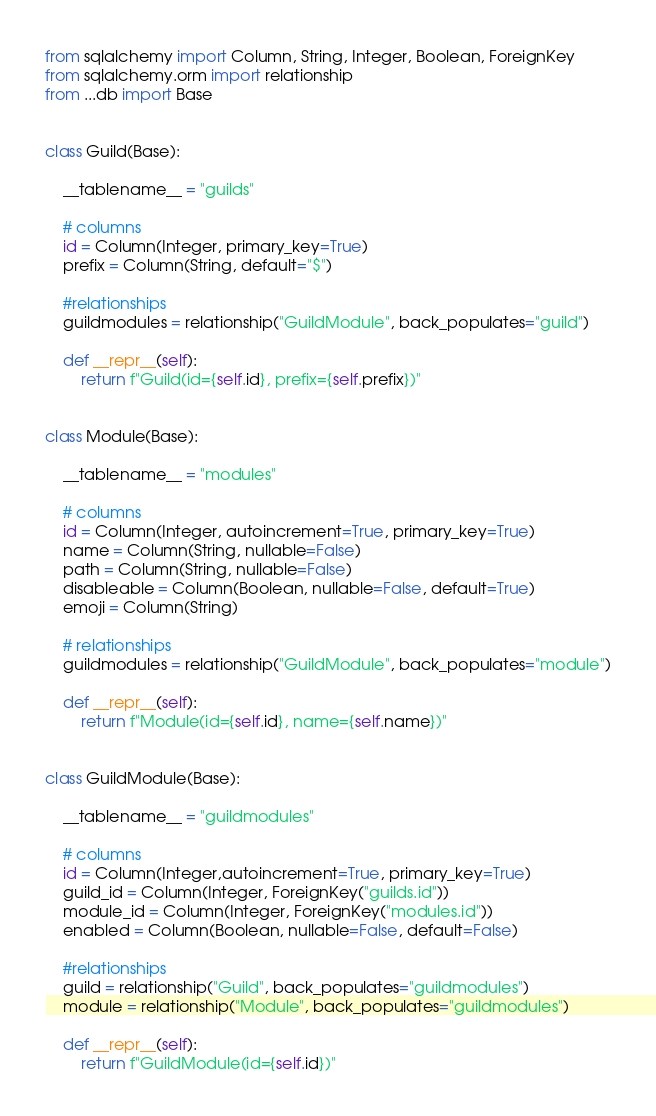Convert code to text. <code><loc_0><loc_0><loc_500><loc_500><_Python_>from sqlalchemy import Column, String, Integer, Boolean, ForeignKey
from sqlalchemy.orm import relationship
from ...db import Base


class Guild(Base):

    __tablename__ = "guilds"

    # columns
    id = Column(Integer, primary_key=True)
    prefix = Column(String, default="$")

    #relationships
    guildmodules = relationship("GuildModule", back_populates="guild")

    def __repr__(self):
        return f"Guild(id={self.id}, prefix={self.prefix})"


class Module(Base):

    __tablename__ = "modules"

    # columns
    id = Column(Integer, autoincrement=True, primary_key=True)
    name = Column(String, nullable=False)
    path = Column(String, nullable=False)
    disableable = Column(Boolean, nullable=False, default=True)
    emoji = Column(String)

    # relationships
    guildmodules = relationship("GuildModule", back_populates="module")

    def __repr__(self):
        return f"Module(id={self.id}, name={self.name})"


class GuildModule(Base):

    __tablename__ = "guildmodules"

    # columns
    id = Column(Integer,autoincrement=True, primary_key=True)
    guild_id = Column(Integer, ForeignKey("guilds.id"))
    module_id = Column(Integer, ForeignKey("modules.id"))
    enabled = Column(Boolean, nullable=False, default=False)

    #relationships
    guild = relationship("Guild", back_populates="guildmodules")
    module = relationship("Module", back_populates="guildmodules")

    def __repr__(self):
        return f"GuildModule(id={self.id})"



</code> 